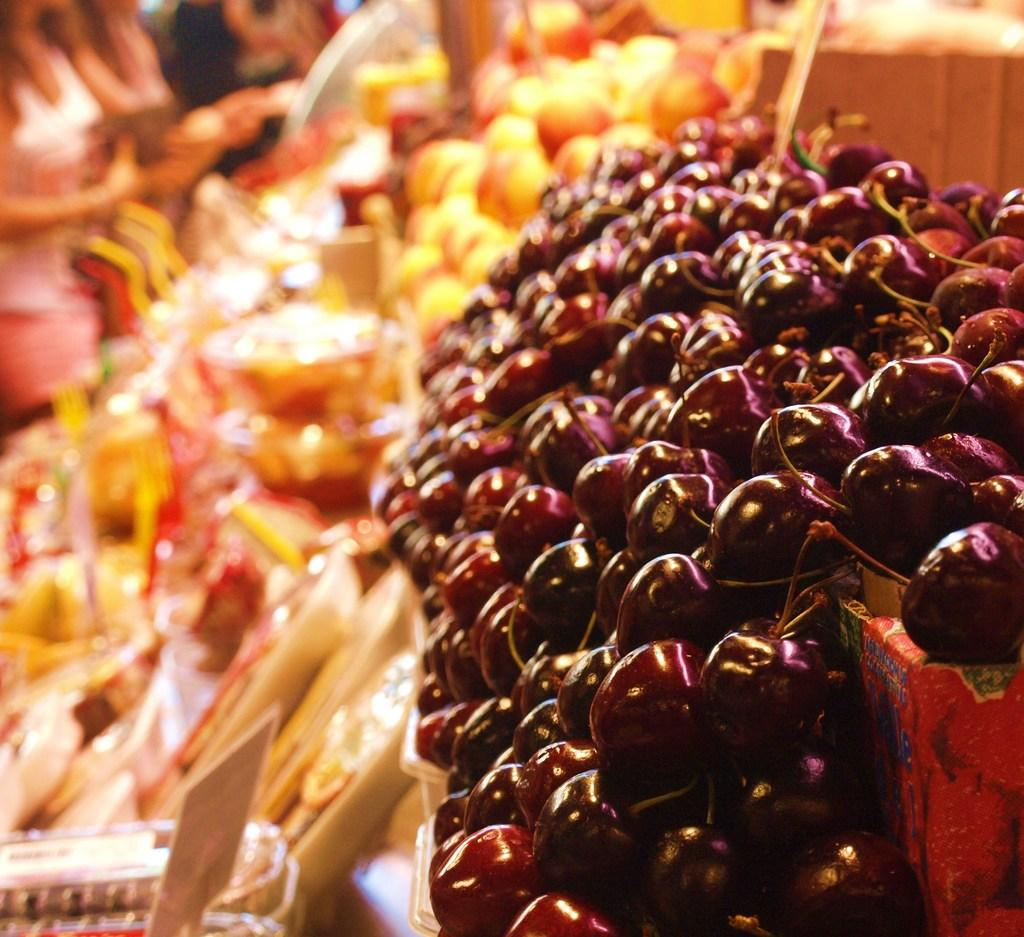What type of food items are present in the image? There are vegetables in the image. Can you describe any other objects or items in the image? There are other unspecified things in the image. What can be seen in the background of the image? There are people in the background of the image. How is the background of the image depicted? The background of the image is blurred. What hobbies do the people in the background of the image enjoy? There is no information provided about the hobbies of the people in the background of the image. 